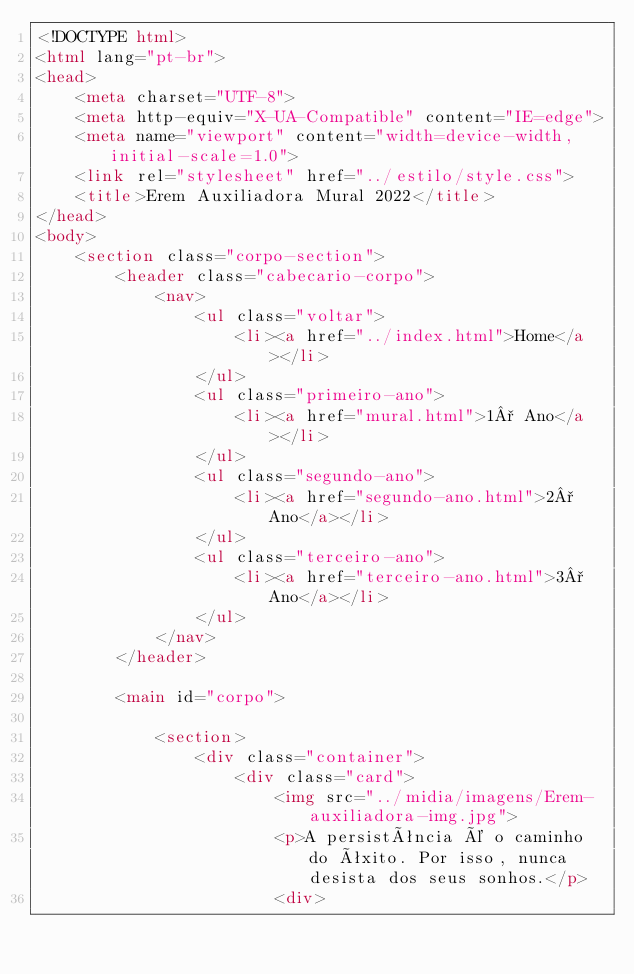Convert code to text. <code><loc_0><loc_0><loc_500><loc_500><_HTML_><!DOCTYPE html>
<html lang="pt-br">
<head>
    <meta charset="UTF-8">
    <meta http-equiv="X-UA-Compatible" content="IE=edge">
    <meta name="viewport" content="width=device-width, initial-scale=1.0">
    <link rel="stylesheet" href="../estilo/style.css">
    <title>Erem Auxiliadora Mural 2022</title>
</head>
<body>
    <section class="corpo-section">
        <header class="cabecario-corpo">
            <nav>
                <ul class="voltar">
                    <li><a href="../index.html">Home</a></li>
                </ul>
                <ul class="primeiro-ano">
                    <li><a href="mural.html">1° Ano</a></li>
                </ul>
                <ul class="segundo-ano">
                    <li><a href="segundo-ano.html">2° Ano</a></li>
                </ul>
                <ul class="terceiro-ano">
                    <li><a href="terceiro-ano.html">3° Ano</a></li>
                </ul>
            </nav>
        </header>

        <main id="corpo">

            <section>
                <div class="container">
                    <div class="card">
                        <img src="../midia/imagens/Erem-auxiliadora-img.jpg">
                        <p>A persistência é o caminho do êxito. Por isso, nunca desista dos seus sonhos.</p>
                        <div></code> 